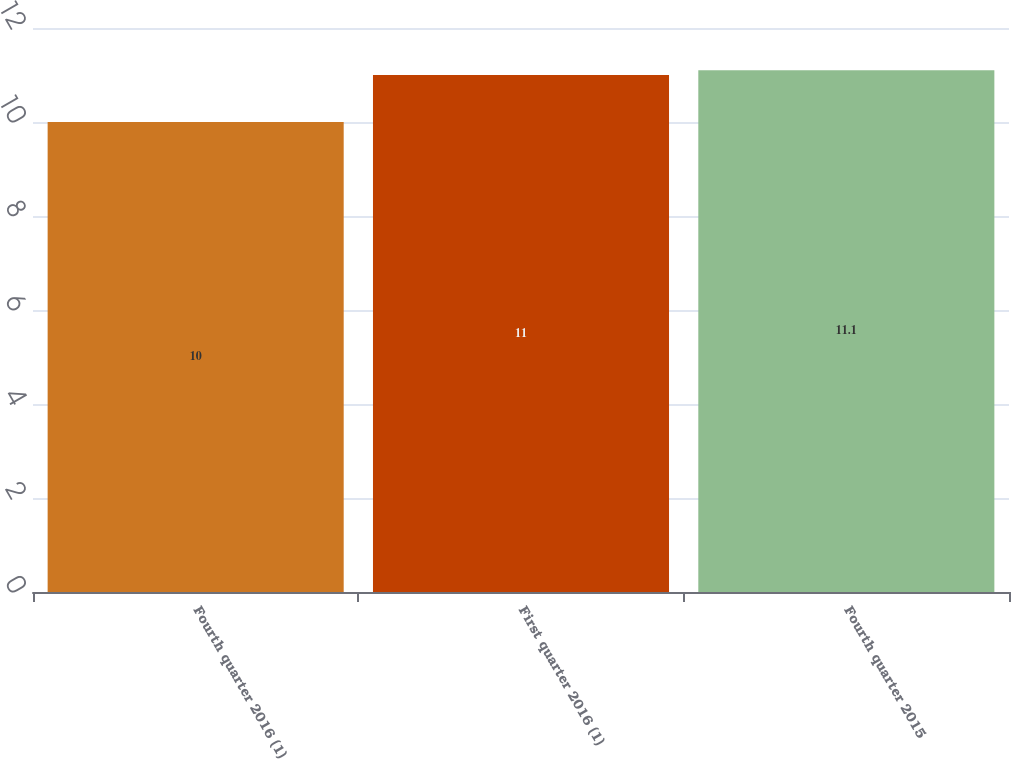Convert chart to OTSL. <chart><loc_0><loc_0><loc_500><loc_500><bar_chart><fcel>Fourth quarter 2016 (1)<fcel>First quarter 2016 (1)<fcel>Fourth quarter 2015<nl><fcel>10<fcel>11<fcel>11.1<nl></chart> 